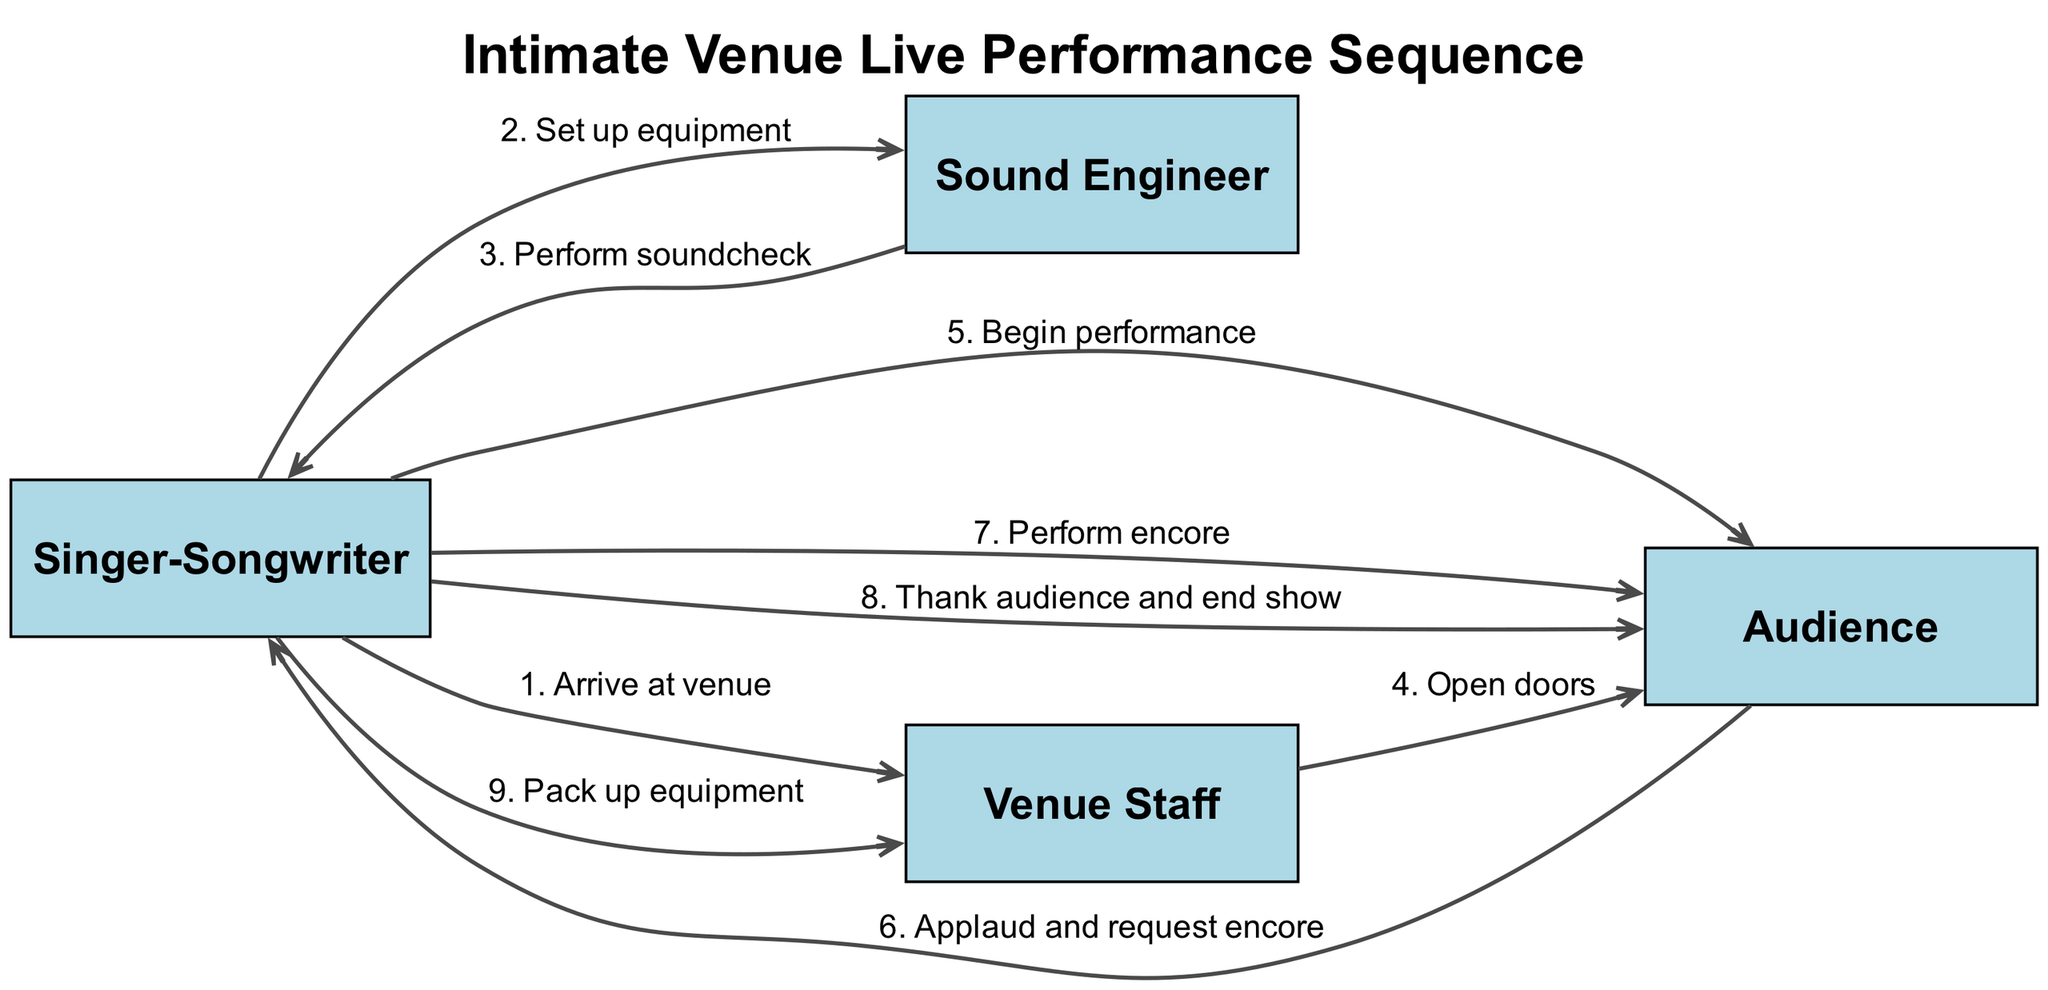What actor is involved in the beginning of the sequence? The first event shows the "Singer-Songwriter" arriving at the venue. This indicates that the "Singer-Songwriter" is the initial actor in this sequence.
Answer: Singer-Songwriter How many actions are performed by the "Singer-Songwriter"? The "Singer-Songwriter" performs three distinct actions: setting up equipment, beginning the performance, and performing an encore. Counting these, we find there are three actions performed by them.
Answer: Three What action follows the soundcheck? After the "Sound Engineer" finishes performing the soundcheck, the next action involves the "Venue Staff" opening the doors for the audience. Thus, it can be determined that this is the action that follows the soundcheck.
Answer: Open doors Which actor receives applause from the audience? The "Audience" applauds and requests an encore from the "Singer-Songwriter." This indicates that the applause is directed towards the "Singer-Songwriter."
Answer: Singer-Songwriter What happens after the audience requests an encore? Following the audience's request for an encore, the "Singer-Songwriter" performs the encore as indicated in the sequence. Therefore, the action that occurs next is the performance of the encore.
Answer: Perform encore Which action is the penultimate in the sequence? The second-to-last action in the sequence is where the "Singer-Songwriter" thanks the audience and ends the show. By counting from the end of the sequence, we can confirm this is the second last action.
Answer: Thank audience and end show How many actors are involved in the sequence? The sequence comprises four actors: the "Singer-Songwriter," "Sound Engineer," "Audience," and "Venue Staff." By counting these actors, we arrive at four in total.
Answer: Four What is the final action in the sequence? The last action in the sequence shows the "Singer-Songwriter" packing up equipment after thanking the audience and ending the show. Thus, the final action is to pack up the equipment.
Answer: Pack up equipment What does the "Venue Staff" do before the performance starts? Before the "Singer-Songwriter" begins the performance, the "Venue Staff" opens the doors, allowing the audience to enter and await the performance. This action occurs before the singer starts.
Answer: Open doors 